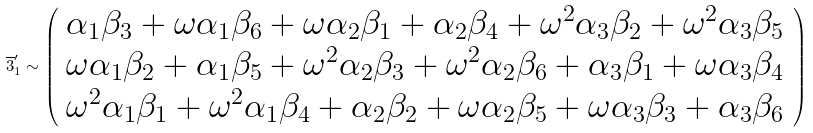<formula> <loc_0><loc_0><loc_500><loc_500>\overline { 3 } ^ { \prime } _ { 1 } \sim \left ( \begin{array} { c } \alpha _ { 1 } \beta _ { 3 } + \omega \alpha _ { 1 } \beta _ { 6 } + \omega \alpha _ { 2 } \beta _ { 1 } + \alpha _ { 2 } \beta _ { 4 } + \omega ^ { 2 } \alpha _ { 3 } \beta _ { 2 } + \omega ^ { 2 } \alpha _ { 3 } \beta _ { 5 } \\ \omega \alpha _ { 1 } \beta _ { 2 } + \alpha _ { 1 } \beta _ { 5 } + \omega ^ { 2 } \alpha _ { 2 } \beta _ { 3 } + \omega ^ { 2 } \alpha _ { 2 } \beta _ { 6 } + \alpha _ { 3 } \beta _ { 1 } + \omega \alpha _ { 3 } \beta _ { 4 } \\ \omega ^ { 2 } \alpha _ { 1 } \beta _ { 1 } + \omega ^ { 2 } \alpha _ { 1 } \beta _ { 4 } + \alpha _ { 2 } \beta _ { 2 } + \omega \alpha _ { 2 } \beta _ { 5 } + \omega \alpha _ { 3 } \beta _ { 3 } + \alpha _ { 3 } \beta _ { 6 } \end{array} \right )</formula> 